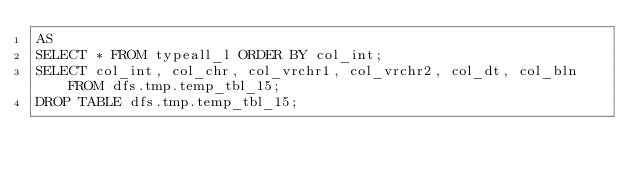<code> <loc_0><loc_0><loc_500><loc_500><_SQL_>AS
SELECT * FROM typeall_l ORDER BY col_int;
SELECT col_int, col_chr, col_vrchr1, col_vrchr2, col_dt, col_bln FROM dfs.tmp.temp_tbl_15;
DROP TABLE dfs.tmp.temp_tbl_15;
</code> 